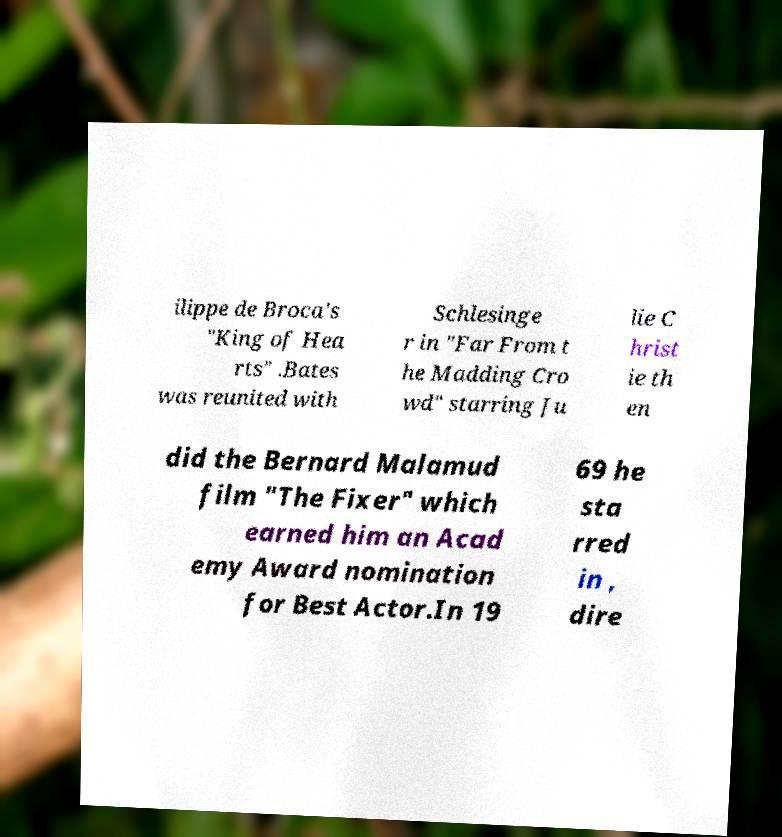Can you read and provide the text displayed in the image?This photo seems to have some interesting text. Can you extract and type it out for me? ilippe de Broca's "King of Hea rts" .Bates was reunited with Schlesinge r in "Far From t he Madding Cro wd" starring Ju lie C hrist ie th en did the Bernard Malamud film "The Fixer" which earned him an Acad emy Award nomination for Best Actor.In 19 69 he sta rred in , dire 